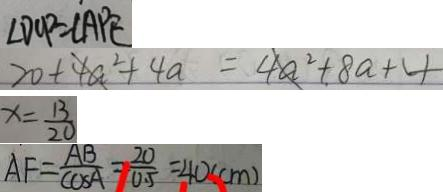Convert formula to latex. <formula><loc_0><loc_0><loc_500><loc_500>\angle D C P = \angle A P E 
 2 0 + 4 a ^ { 2 } + 4 a = 4 a ^ { 2 } + 8 a + 4 
 x = \frac { 1 3 } { 2 0 } 
 A F = \frac { A B } { \cos A } = \frac { 2 0 } { 0 . 5 } = 4 0 ( c m )</formula> 